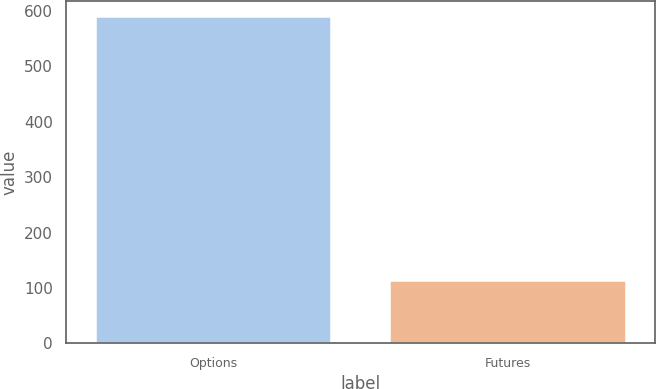Convert chart. <chart><loc_0><loc_0><loc_500><loc_500><bar_chart><fcel>Options<fcel>Futures<nl><fcel>589.5<fcel>113.6<nl></chart> 